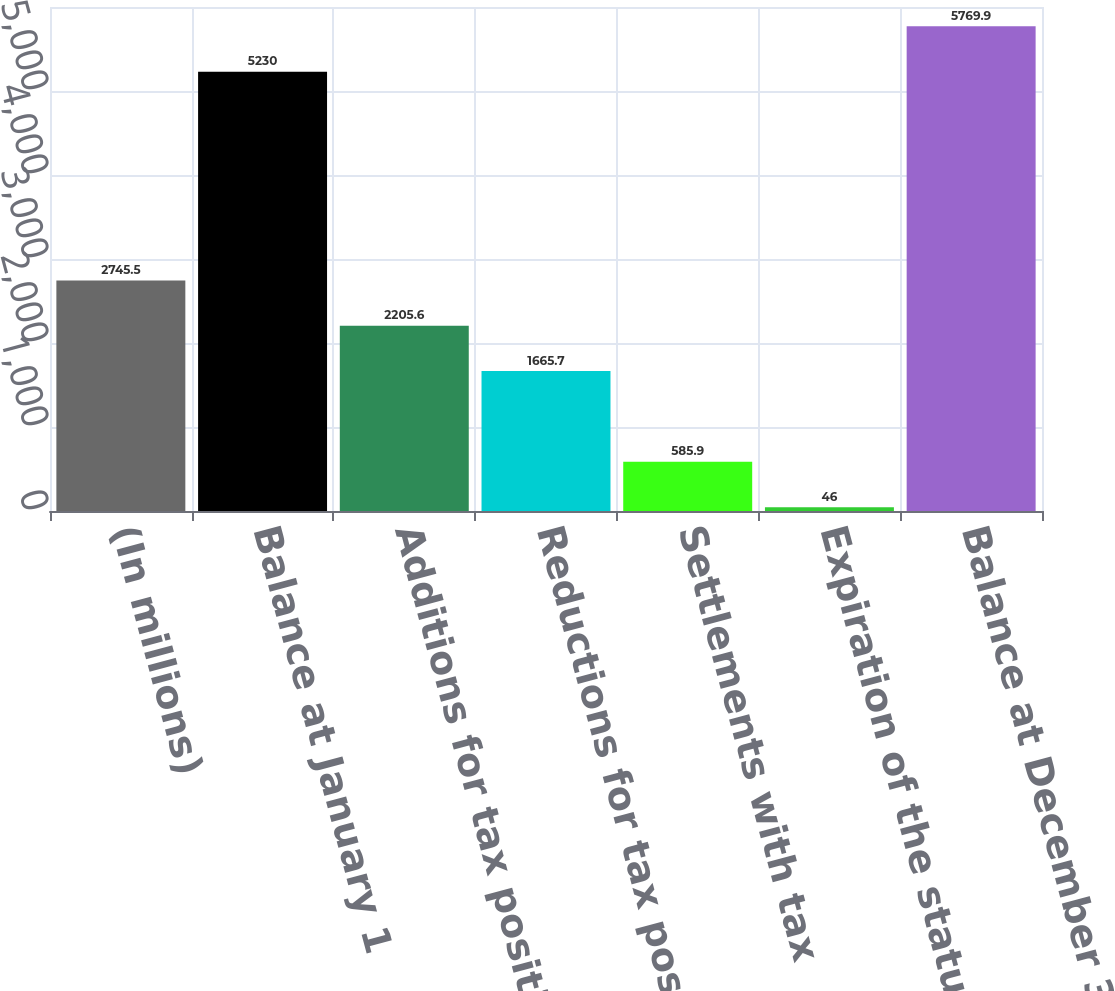<chart> <loc_0><loc_0><loc_500><loc_500><bar_chart><fcel>(In millions)<fcel>Balance at January 1<fcel>Additions for tax positions of<fcel>Reductions for tax positions<fcel>Settlements with tax<fcel>Expiration of the statute of<fcel>Balance at December 31<nl><fcel>2745.5<fcel>5230<fcel>2205.6<fcel>1665.7<fcel>585.9<fcel>46<fcel>5769.9<nl></chart> 